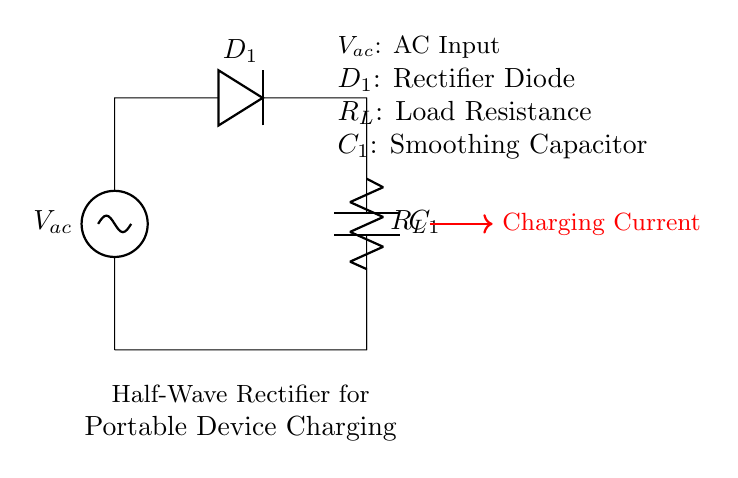What type of rectifier is shown in the diagram? The diagram represents a half-wave rectifier, which allows only one half of the AC waveform to pass through to the load. This is identifiable by the single diode configuration connected in series with the load.
Answer: half-wave rectifier What is the function of the diode in this circuit? The diode, labeled as D1, is responsible for allowing current to flow in only one direction, hence it prevents the reverse flow of current during the negative half cycle of the AC input. This is crucial for conversion of AC to DC.
Answer: allows current flow one direction What component smooths the rectified voltage? The component that smooths the rectified voltage in the circuit is the capacitor labeled C1. It stores charge and releases it, thereby smoothing out the fluctuations in voltage after rectification.
Answer: smoothing capacitor What is the load connected to in this circuit? The load in this circuit is connected to the resistor labeled R_L, which represents the portable device that will be charged. The value of the resistor determines the amount of current flow to the device being powered.
Answer: resistor How does the charging current flow during operation? During the positive half-cycle of the AC input voltage, the diode conducts, allowing charging current to flow through the load resistor and into the smoothing capacitor, where it accumulates and stabilizes.
Answer: through the load resistor What happens to the current during the negative half-cycle? During the negative half-cycle of the AC input voltage, the diode becomes reverse-biased, blocking current from passing through. This results in no current flow to the load, effectively stopping the charging process at that time.
Answer: current flow stops What role does the load resistor play in the circuit? The load resistor R_L limits the amount of current flowing to the connected portable device, protecting it from excessive current that could potentially cause damage. It also serves as the point where AC voltage is converted into usable DC voltage for the device.
Answer: limits current flow 